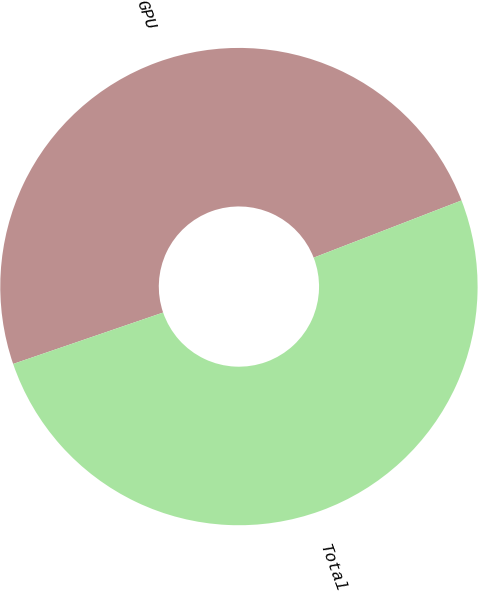Convert chart. <chart><loc_0><loc_0><loc_500><loc_500><pie_chart><fcel>GPU<fcel>Total<nl><fcel>49.38%<fcel>50.62%<nl></chart> 